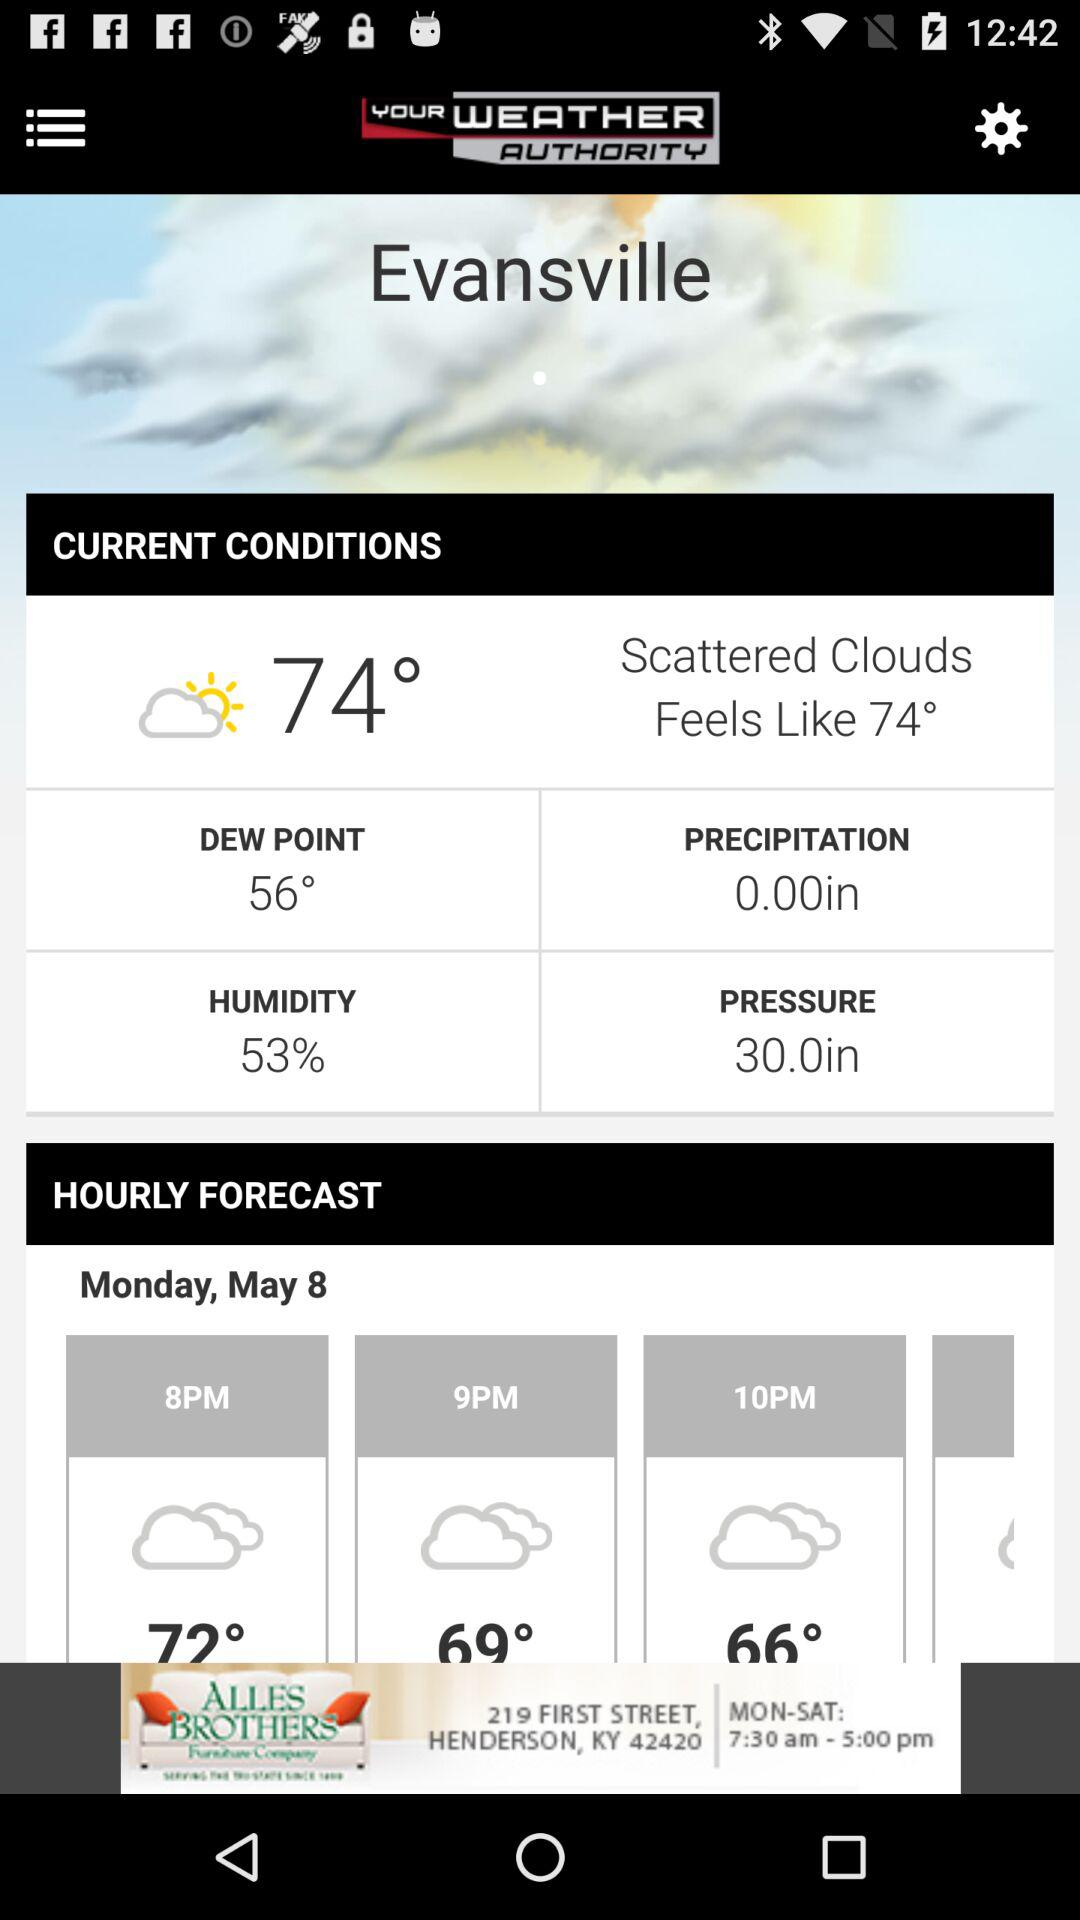What is the temperature on Monday at 10 PM? The temperature is 66°. 